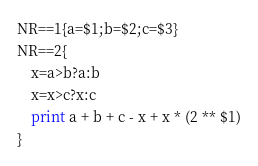<code> <loc_0><loc_0><loc_500><loc_500><_Awk_>NR==1{a=$1;b=$2;c=$3}
NR==2{
    x=a>b?a:b
    x=x>c?x:c
    print a + b + c - x + x * (2 ** $1)
}
</code> 